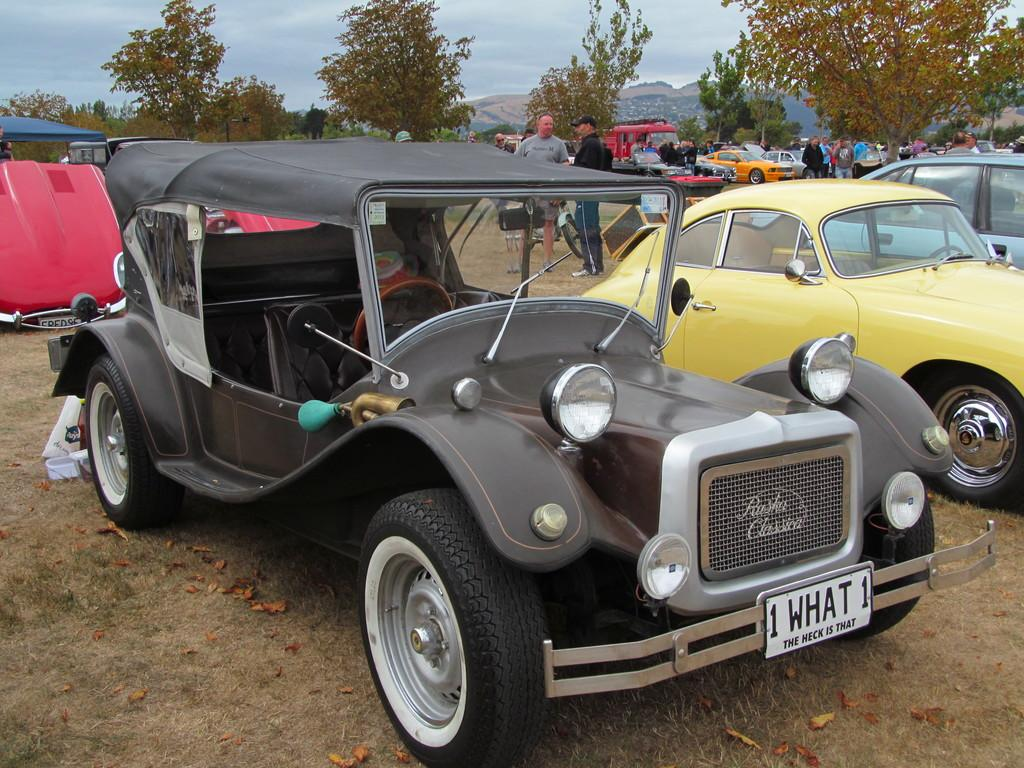What types of objects can be seen in the image? There are vehicles in the image. What else can be seen in the image besides the vehicles? There is a group of people standing in the image, as well as trees. What can be seen in the background of the image? The sky is visible in the background of the image. What type of note is being passed between the trees in the image? There is no note being passed between the trees in the image; the trees are stationary and not engaged in any activity. 